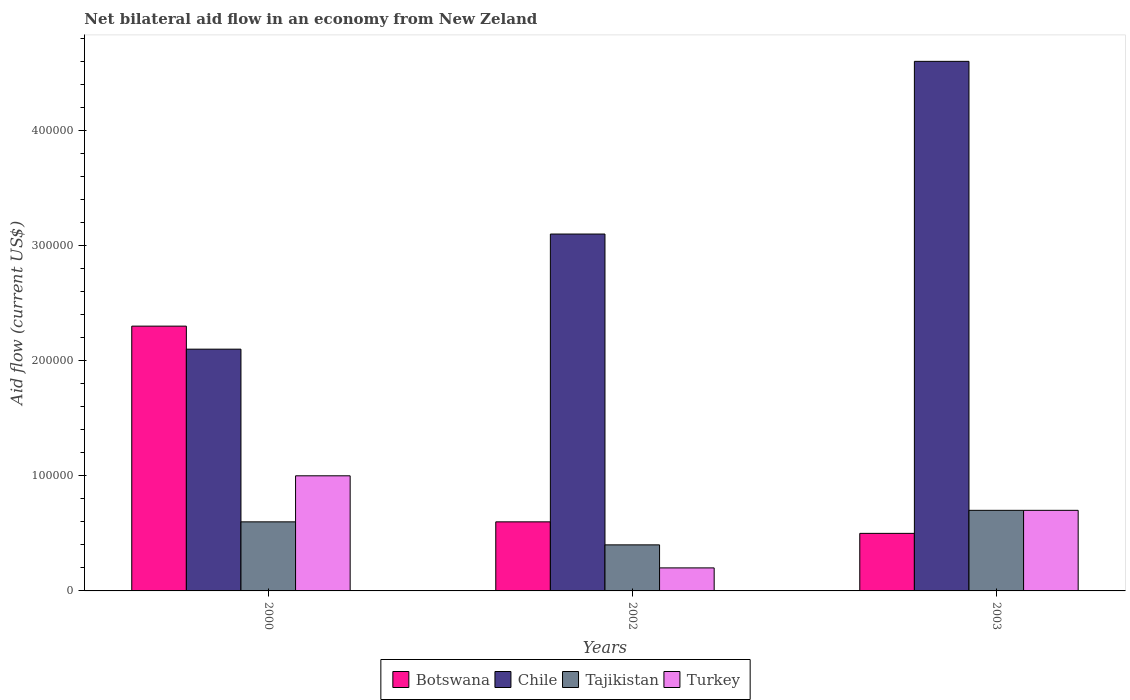How many groups of bars are there?
Provide a succinct answer. 3. Are the number of bars per tick equal to the number of legend labels?
Your answer should be compact. Yes. Are the number of bars on each tick of the X-axis equal?
Your answer should be compact. Yes. How many bars are there on the 3rd tick from the left?
Your response must be concise. 4. How many bars are there on the 3rd tick from the right?
Provide a short and direct response. 4. What is the label of the 1st group of bars from the left?
Your answer should be very brief. 2000. In how many cases, is the number of bars for a given year not equal to the number of legend labels?
Your answer should be very brief. 0. What is the net bilateral aid flow in Chile in 2000?
Your answer should be compact. 2.10e+05. Across all years, what is the maximum net bilateral aid flow in Tajikistan?
Offer a terse response. 7.00e+04. Across all years, what is the minimum net bilateral aid flow in Tajikistan?
Offer a very short reply. 4.00e+04. In which year was the net bilateral aid flow in Botswana maximum?
Your answer should be very brief. 2000. In which year was the net bilateral aid flow in Tajikistan minimum?
Give a very brief answer. 2002. What is the total net bilateral aid flow in Chile in the graph?
Keep it short and to the point. 9.80e+05. What is the difference between the net bilateral aid flow in Turkey in 2000 and the net bilateral aid flow in Chile in 2002?
Provide a short and direct response. -2.10e+05. What is the average net bilateral aid flow in Botswana per year?
Make the answer very short. 1.13e+05. In how many years, is the net bilateral aid flow in Chile greater than 360000 US$?
Give a very brief answer. 1. What is the ratio of the net bilateral aid flow in Tajikistan in 2000 to that in 2003?
Offer a very short reply. 0.86. Is the difference between the net bilateral aid flow in Botswana in 2000 and 2003 greater than the difference between the net bilateral aid flow in Chile in 2000 and 2003?
Provide a short and direct response. Yes. What is the difference between the highest and the lowest net bilateral aid flow in Botswana?
Make the answer very short. 1.80e+05. In how many years, is the net bilateral aid flow in Tajikistan greater than the average net bilateral aid flow in Tajikistan taken over all years?
Give a very brief answer. 2. What does the 4th bar from the right in 2003 represents?
Your answer should be very brief. Botswana. How many bars are there?
Provide a succinct answer. 12. How many years are there in the graph?
Give a very brief answer. 3. What is the difference between two consecutive major ticks on the Y-axis?
Your answer should be very brief. 1.00e+05. Are the values on the major ticks of Y-axis written in scientific E-notation?
Ensure brevity in your answer.  No. Does the graph contain grids?
Offer a very short reply. No. How many legend labels are there?
Keep it short and to the point. 4. How are the legend labels stacked?
Make the answer very short. Horizontal. What is the title of the graph?
Your answer should be very brief. Net bilateral aid flow in an economy from New Zeland. Does "Bulgaria" appear as one of the legend labels in the graph?
Your response must be concise. No. What is the Aid flow (current US$) of Tajikistan in 2000?
Provide a succinct answer. 6.00e+04. What is the Aid flow (current US$) in Turkey in 2000?
Give a very brief answer. 1.00e+05. What is the Aid flow (current US$) in Botswana in 2002?
Keep it short and to the point. 6.00e+04. What is the Aid flow (current US$) of Botswana in 2003?
Your response must be concise. 5.00e+04. What is the Aid flow (current US$) of Chile in 2003?
Provide a short and direct response. 4.60e+05. What is the Aid flow (current US$) of Tajikistan in 2003?
Your answer should be very brief. 7.00e+04. What is the Aid flow (current US$) of Turkey in 2003?
Offer a very short reply. 7.00e+04. Across all years, what is the maximum Aid flow (current US$) in Botswana?
Offer a terse response. 2.30e+05. Across all years, what is the maximum Aid flow (current US$) of Chile?
Your response must be concise. 4.60e+05. Across all years, what is the minimum Aid flow (current US$) of Botswana?
Ensure brevity in your answer.  5.00e+04. What is the total Aid flow (current US$) in Chile in the graph?
Make the answer very short. 9.80e+05. What is the difference between the Aid flow (current US$) in Botswana in 2000 and that in 2002?
Offer a very short reply. 1.70e+05. What is the difference between the Aid flow (current US$) in Chile in 2000 and that in 2002?
Your answer should be compact. -1.00e+05. What is the difference between the Aid flow (current US$) in Tajikistan in 2000 and that in 2002?
Make the answer very short. 2.00e+04. What is the difference between the Aid flow (current US$) of Turkey in 2000 and that in 2002?
Your answer should be very brief. 8.00e+04. What is the difference between the Aid flow (current US$) in Chile in 2000 and that in 2003?
Offer a terse response. -2.50e+05. What is the difference between the Aid flow (current US$) of Botswana in 2002 and that in 2003?
Your response must be concise. 10000. What is the difference between the Aid flow (current US$) in Chile in 2002 and that in 2003?
Ensure brevity in your answer.  -1.50e+05. What is the difference between the Aid flow (current US$) in Tajikistan in 2002 and that in 2003?
Your response must be concise. -3.00e+04. What is the difference between the Aid flow (current US$) in Turkey in 2002 and that in 2003?
Offer a terse response. -5.00e+04. What is the difference between the Aid flow (current US$) in Botswana in 2000 and the Aid flow (current US$) in Chile in 2002?
Offer a terse response. -8.00e+04. What is the difference between the Aid flow (current US$) of Botswana in 2000 and the Aid flow (current US$) of Tajikistan in 2002?
Ensure brevity in your answer.  1.90e+05. What is the difference between the Aid flow (current US$) of Chile in 2000 and the Aid flow (current US$) of Turkey in 2002?
Your answer should be very brief. 1.90e+05. What is the difference between the Aid flow (current US$) of Botswana in 2000 and the Aid flow (current US$) of Chile in 2003?
Give a very brief answer. -2.30e+05. What is the difference between the Aid flow (current US$) of Chile in 2000 and the Aid flow (current US$) of Turkey in 2003?
Give a very brief answer. 1.40e+05. What is the difference between the Aid flow (current US$) of Botswana in 2002 and the Aid flow (current US$) of Chile in 2003?
Ensure brevity in your answer.  -4.00e+05. What is the difference between the Aid flow (current US$) of Botswana in 2002 and the Aid flow (current US$) of Tajikistan in 2003?
Offer a terse response. -10000. What is the difference between the Aid flow (current US$) in Botswana in 2002 and the Aid flow (current US$) in Turkey in 2003?
Give a very brief answer. -10000. What is the difference between the Aid flow (current US$) of Chile in 2002 and the Aid flow (current US$) of Turkey in 2003?
Offer a terse response. 2.40e+05. What is the average Aid flow (current US$) of Botswana per year?
Ensure brevity in your answer.  1.13e+05. What is the average Aid flow (current US$) of Chile per year?
Provide a succinct answer. 3.27e+05. What is the average Aid flow (current US$) in Tajikistan per year?
Offer a terse response. 5.67e+04. What is the average Aid flow (current US$) in Turkey per year?
Make the answer very short. 6.33e+04. In the year 2000, what is the difference between the Aid flow (current US$) of Botswana and Aid flow (current US$) of Chile?
Provide a short and direct response. 2.00e+04. In the year 2000, what is the difference between the Aid flow (current US$) of Botswana and Aid flow (current US$) of Tajikistan?
Make the answer very short. 1.70e+05. In the year 2000, what is the difference between the Aid flow (current US$) in Chile and Aid flow (current US$) in Turkey?
Give a very brief answer. 1.10e+05. In the year 2000, what is the difference between the Aid flow (current US$) in Tajikistan and Aid flow (current US$) in Turkey?
Your response must be concise. -4.00e+04. In the year 2002, what is the difference between the Aid flow (current US$) in Botswana and Aid flow (current US$) in Chile?
Provide a short and direct response. -2.50e+05. In the year 2002, what is the difference between the Aid flow (current US$) of Botswana and Aid flow (current US$) of Tajikistan?
Offer a very short reply. 2.00e+04. In the year 2002, what is the difference between the Aid flow (current US$) of Botswana and Aid flow (current US$) of Turkey?
Offer a very short reply. 4.00e+04. In the year 2002, what is the difference between the Aid flow (current US$) in Chile and Aid flow (current US$) in Tajikistan?
Offer a terse response. 2.70e+05. In the year 2003, what is the difference between the Aid flow (current US$) of Botswana and Aid flow (current US$) of Chile?
Your answer should be compact. -4.10e+05. In the year 2003, what is the difference between the Aid flow (current US$) of Botswana and Aid flow (current US$) of Turkey?
Keep it short and to the point. -2.00e+04. What is the ratio of the Aid flow (current US$) of Botswana in 2000 to that in 2002?
Keep it short and to the point. 3.83. What is the ratio of the Aid flow (current US$) of Chile in 2000 to that in 2002?
Give a very brief answer. 0.68. What is the ratio of the Aid flow (current US$) in Botswana in 2000 to that in 2003?
Offer a very short reply. 4.6. What is the ratio of the Aid flow (current US$) in Chile in 2000 to that in 2003?
Make the answer very short. 0.46. What is the ratio of the Aid flow (current US$) in Turkey in 2000 to that in 2003?
Offer a very short reply. 1.43. What is the ratio of the Aid flow (current US$) of Botswana in 2002 to that in 2003?
Offer a terse response. 1.2. What is the ratio of the Aid flow (current US$) of Chile in 2002 to that in 2003?
Give a very brief answer. 0.67. What is the ratio of the Aid flow (current US$) of Tajikistan in 2002 to that in 2003?
Ensure brevity in your answer.  0.57. What is the ratio of the Aid flow (current US$) in Turkey in 2002 to that in 2003?
Offer a terse response. 0.29. What is the difference between the highest and the second highest Aid flow (current US$) of Botswana?
Your answer should be very brief. 1.70e+05. What is the difference between the highest and the second highest Aid flow (current US$) of Chile?
Your response must be concise. 1.50e+05. What is the difference between the highest and the second highest Aid flow (current US$) in Tajikistan?
Give a very brief answer. 10000. What is the difference between the highest and the second highest Aid flow (current US$) of Turkey?
Offer a very short reply. 3.00e+04. What is the difference between the highest and the lowest Aid flow (current US$) in Tajikistan?
Keep it short and to the point. 3.00e+04. 